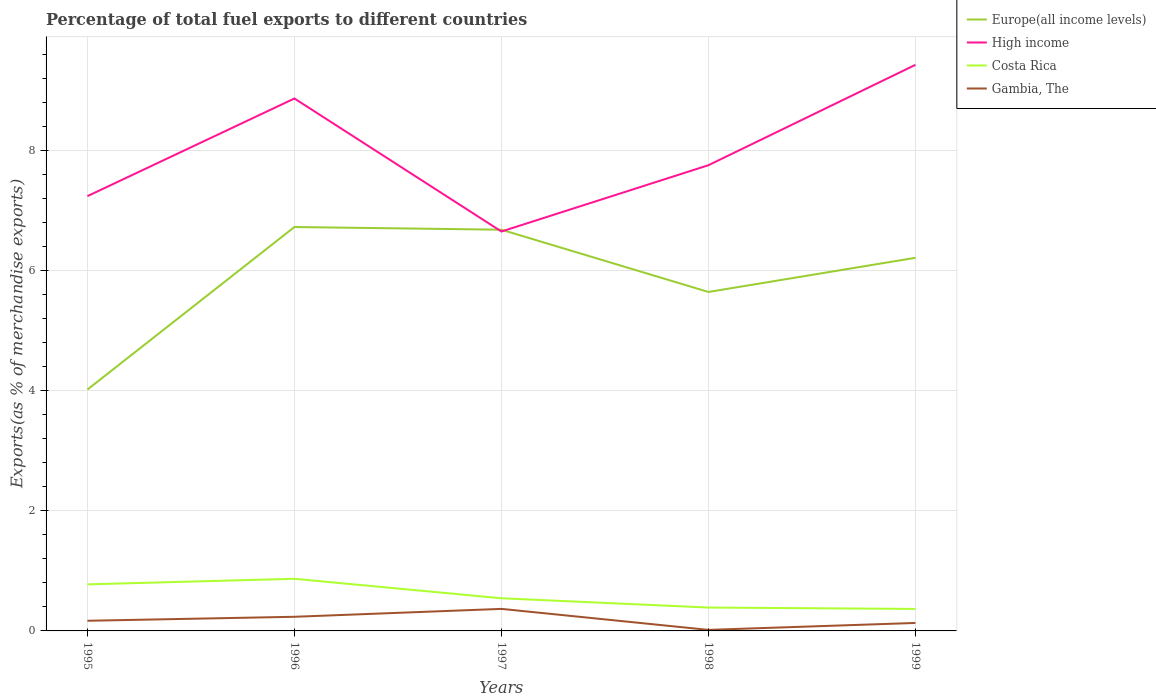How many different coloured lines are there?
Your answer should be very brief. 4. Does the line corresponding to High income intersect with the line corresponding to Europe(all income levels)?
Your answer should be very brief. Yes. Across all years, what is the maximum percentage of exports to different countries in Gambia, The?
Offer a very short reply. 0.02. What is the total percentage of exports to different countries in Costa Rica in the graph?
Ensure brevity in your answer.  0.5. What is the difference between the highest and the second highest percentage of exports to different countries in Costa Rica?
Ensure brevity in your answer.  0.5. What is the difference between the highest and the lowest percentage of exports to different countries in High income?
Your response must be concise. 2. How many years are there in the graph?
Offer a very short reply. 5. What is the difference between two consecutive major ticks on the Y-axis?
Provide a short and direct response. 2. Are the values on the major ticks of Y-axis written in scientific E-notation?
Provide a short and direct response. No. Does the graph contain any zero values?
Provide a succinct answer. No. Does the graph contain grids?
Your answer should be very brief. Yes. How are the legend labels stacked?
Your answer should be compact. Vertical. What is the title of the graph?
Offer a terse response. Percentage of total fuel exports to different countries. Does "Bosnia and Herzegovina" appear as one of the legend labels in the graph?
Provide a short and direct response. No. What is the label or title of the X-axis?
Offer a very short reply. Years. What is the label or title of the Y-axis?
Make the answer very short. Exports(as % of merchandise exports). What is the Exports(as % of merchandise exports) of Europe(all income levels) in 1995?
Keep it short and to the point. 4.02. What is the Exports(as % of merchandise exports) in High income in 1995?
Keep it short and to the point. 7.25. What is the Exports(as % of merchandise exports) in Costa Rica in 1995?
Ensure brevity in your answer.  0.78. What is the Exports(as % of merchandise exports) in Gambia, The in 1995?
Keep it short and to the point. 0.17. What is the Exports(as % of merchandise exports) of Europe(all income levels) in 1996?
Offer a very short reply. 6.73. What is the Exports(as % of merchandise exports) in High income in 1996?
Your response must be concise. 8.87. What is the Exports(as % of merchandise exports) of Costa Rica in 1996?
Give a very brief answer. 0.87. What is the Exports(as % of merchandise exports) of Gambia, The in 1996?
Offer a very short reply. 0.24. What is the Exports(as % of merchandise exports) in Europe(all income levels) in 1997?
Give a very brief answer. 6.69. What is the Exports(as % of merchandise exports) in High income in 1997?
Keep it short and to the point. 6.66. What is the Exports(as % of merchandise exports) of Costa Rica in 1997?
Offer a terse response. 0.54. What is the Exports(as % of merchandise exports) of Gambia, The in 1997?
Provide a short and direct response. 0.37. What is the Exports(as % of merchandise exports) of Europe(all income levels) in 1998?
Offer a terse response. 5.65. What is the Exports(as % of merchandise exports) of High income in 1998?
Provide a short and direct response. 7.76. What is the Exports(as % of merchandise exports) in Costa Rica in 1998?
Ensure brevity in your answer.  0.39. What is the Exports(as % of merchandise exports) of Gambia, The in 1998?
Your answer should be very brief. 0.02. What is the Exports(as % of merchandise exports) in Europe(all income levels) in 1999?
Your answer should be compact. 6.22. What is the Exports(as % of merchandise exports) in High income in 1999?
Your response must be concise. 9.44. What is the Exports(as % of merchandise exports) of Costa Rica in 1999?
Offer a very short reply. 0.37. What is the Exports(as % of merchandise exports) of Gambia, The in 1999?
Ensure brevity in your answer.  0.13. Across all years, what is the maximum Exports(as % of merchandise exports) of Europe(all income levels)?
Your answer should be compact. 6.73. Across all years, what is the maximum Exports(as % of merchandise exports) of High income?
Offer a terse response. 9.44. Across all years, what is the maximum Exports(as % of merchandise exports) in Costa Rica?
Provide a short and direct response. 0.87. Across all years, what is the maximum Exports(as % of merchandise exports) in Gambia, The?
Make the answer very short. 0.37. Across all years, what is the minimum Exports(as % of merchandise exports) of Europe(all income levels)?
Offer a very short reply. 4.02. Across all years, what is the minimum Exports(as % of merchandise exports) in High income?
Your answer should be very brief. 6.66. Across all years, what is the minimum Exports(as % of merchandise exports) in Costa Rica?
Make the answer very short. 0.37. Across all years, what is the minimum Exports(as % of merchandise exports) of Gambia, The?
Offer a terse response. 0.02. What is the total Exports(as % of merchandise exports) of Europe(all income levels) in the graph?
Your answer should be very brief. 29.31. What is the total Exports(as % of merchandise exports) of High income in the graph?
Offer a terse response. 39.98. What is the total Exports(as % of merchandise exports) in Costa Rica in the graph?
Your answer should be very brief. 2.95. What is the total Exports(as % of merchandise exports) of Gambia, The in the graph?
Provide a short and direct response. 0.92. What is the difference between the Exports(as % of merchandise exports) in Europe(all income levels) in 1995 and that in 1996?
Provide a short and direct response. -2.71. What is the difference between the Exports(as % of merchandise exports) of High income in 1995 and that in 1996?
Your answer should be compact. -1.63. What is the difference between the Exports(as % of merchandise exports) of Costa Rica in 1995 and that in 1996?
Your response must be concise. -0.09. What is the difference between the Exports(as % of merchandise exports) in Gambia, The in 1995 and that in 1996?
Give a very brief answer. -0.07. What is the difference between the Exports(as % of merchandise exports) of Europe(all income levels) in 1995 and that in 1997?
Offer a terse response. -2.66. What is the difference between the Exports(as % of merchandise exports) in High income in 1995 and that in 1997?
Provide a succinct answer. 0.59. What is the difference between the Exports(as % of merchandise exports) in Costa Rica in 1995 and that in 1997?
Your answer should be very brief. 0.23. What is the difference between the Exports(as % of merchandise exports) of Gambia, The in 1995 and that in 1997?
Your answer should be very brief. -0.2. What is the difference between the Exports(as % of merchandise exports) of Europe(all income levels) in 1995 and that in 1998?
Your answer should be very brief. -1.63. What is the difference between the Exports(as % of merchandise exports) of High income in 1995 and that in 1998?
Give a very brief answer. -0.52. What is the difference between the Exports(as % of merchandise exports) of Costa Rica in 1995 and that in 1998?
Keep it short and to the point. 0.39. What is the difference between the Exports(as % of merchandise exports) in Gambia, The in 1995 and that in 1998?
Make the answer very short. 0.15. What is the difference between the Exports(as % of merchandise exports) of Europe(all income levels) in 1995 and that in 1999?
Your answer should be very brief. -2.2. What is the difference between the Exports(as % of merchandise exports) of High income in 1995 and that in 1999?
Offer a very short reply. -2.19. What is the difference between the Exports(as % of merchandise exports) in Costa Rica in 1995 and that in 1999?
Your response must be concise. 0.41. What is the difference between the Exports(as % of merchandise exports) of Gambia, The in 1995 and that in 1999?
Keep it short and to the point. 0.04. What is the difference between the Exports(as % of merchandise exports) of Europe(all income levels) in 1996 and that in 1997?
Provide a succinct answer. 0.04. What is the difference between the Exports(as % of merchandise exports) in High income in 1996 and that in 1997?
Offer a very short reply. 2.22. What is the difference between the Exports(as % of merchandise exports) in Costa Rica in 1996 and that in 1997?
Provide a short and direct response. 0.32. What is the difference between the Exports(as % of merchandise exports) in Gambia, The in 1996 and that in 1997?
Provide a succinct answer. -0.13. What is the difference between the Exports(as % of merchandise exports) in Europe(all income levels) in 1996 and that in 1998?
Ensure brevity in your answer.  1.08. What is the difference between the Exports(as % of merchandise exports) of High income in 1996 and that in 1998?
Your answer should be very brief. 1.11. What is the difference between the Exports(as % of merchandise exports) in Costa Rica in 1996 and that in 1998?
Ensure brevity in your answer.  0.48. What is the difference between the Exports(as % of merchandise exports) of Gambia, The in 1996 and that in 1998?
Keep it short and to the point. 0.22. What is the difference between the Exports(as % of merchandise exports) of Europe(all income levels) in 1996 and that in 1999?
Provide a short and direct response. 0.51. What is the difference between the Exports(as % of merchandise exports) in High income in 1996 and that in 1999?
Your answer should be compact. -0.56. What is the difference between the Exports(as % of merchandise exports) of Costa Rica in 1996 and that in 1999?
Your response must be concise. 0.5. What is the difference between the Exports(as % of merchandise exports) in Gambia, The in 1996 and that in 1999?
Provide a short and direct response. 0.1. What is the difference between the Exports(as % of merchandise exports) in Europe(all income levels) in 1997 and that in 1998?
Keep it short and to the point. 1.04. What is the difference between the Exports(as % of merchandise exports) of High income in 1997 and that in 1998?
Offer a very short reply. -1.1. What is the difference between the Exports(as % of merchandise exports) of Costa Rica in 1997 and that in 1998?
Offer a very short reply. 0.15. What is the difference between the Exports(as % of merchandise exports) in Gambia, The in 1997 and that in 1998?
Your response must be concise. 0.35. What is the difference between the Exports(as % of merchandise exports) of Europe(all income levels) in 1997 and that in 1999?
Keep it short and to the point. 0.47. What is the difference between the Exports(as % of merchandise exports) in High income in 1997 and that in 1999?
Your response must be concise. -2.78. What is the difference between the Exports(as % of merchandise exports) of Costa Rica in 1997 and that in 1999?
Your answer should be very brief. 0.18. What is the difference between the Exports(as % of merchandise exports) in Gambia, The in 1997 and that in 1999?
Keep it short and to the point. 0.23. What is the difference between the Exports(as % of merchandise exports) of Europe(all income levels) in 1998 and that in 1999?
Your response must be concise. -0.57. What is the difference between the Exports(as % of merchandise exports) of High income in 1998 and that in 1999?
Provide a succinct answer. -1.67. What is the difference between the Exports(as % of merchandise exports) of Costa Rica in 1998 and that in 1999?
Offer a very short reply. 0.02. What is the difference between the Exports(as % of merchandise exports) of Gambia, The in 1998 and that in 1999?
Offer a very short reply. -0.12. What is the difference between the Exports(as % of merchandise exports) in Europe(all income levels) in 1995 and the Exports(as % of merchandise exports) in High income in 1996?
Provide a short and direct response. -4.85. What is the difference between the Exports(as % of merchandise exports) in Europe(all income levels) in 1995 and the Exports(as % of merchandise exports) in Costa Rica in 1996?
Ensure brevity in your answer.  3.15. What is the difference between the Exports(as % of merchandise exports) in Europe(all income levels) in 1995 and the Exports(as % of merchandise exports) in Gambia, The in 1996?
Give a very brief answer. 3.79. What is the difference between the Exports(as % of merchandise exports) of High income in 1995 and the Exports(as % of merchandise exports) of Costa Rica in 1996?
Keep it short and to the point. 6.38. What is the difference between the Exports(as % of merchandise exports) of High income in 1995 and the Exports(as % of merchandise exports) of Gambia, The in 1996?
Your answer should be very brief. 7.01. What is the difference between the Exports(as % of merchandise exports) of Costa Rica in 1995 and the Exports(as % of merchandise exports) of Gambia, The in 1996?
Provide a short and direct response. 0.54. What is the difference between the Exports(as % of merchandise exports) in Europe(all income levels) in 1995 and the Exports(as % of merchandise exports) in High income in 1997?
Give a very brief answer. -2.63. What is the difference between the Exports(as % of merchandise exports) in Europe(all income levels) in 1995 and the Exports(as % of merchandise exports) in Costa Rica in 1997?
Offer a terse response. 3.48. What is the difference between the Exports(as % of merchandise exports) in Europe(all income levels) in 1995 and the Exports(as % of merchandise exports) in Gambia, The in 1997?
Give a very brief answer. 3.66. What is the difference between the Exports(as % of merchandise exports) of High income in 1995 and the Exports(as % of merchandise exports) of Costa Rica in 1997?
Provide a succinct answer. 6.7. What is the difference between the Exports(as % of merchandise exports) of High income in 1995 and the Exports(as % of merchandise exports) of Gambia, The in 1997?
Provide a succinct answer. 6.88. What is the difference between the Exports(as % of merchandise exports) of Costa Rica in 1995 and the Exports(as % of merchandise exports) of Gambia, The in 1997?
Make the answer very short. 0.41. What is the difference between the Exports(as % of merchandise exports) in Europe(all income levels) in 1995 and the Exports(as % of merchandise exports) in High income in 1998?
Provide a succinct answer. -3.74. What is the difference between the Exports(as % of merchandise exports) of Europe(all income levels) in 1995 and the Exports(as % of merchandise exports) of Costa Rica in 1998?
Keep it short and to the point. 3.63. What is the difference between the Exports(as % of merchandise exports) in Europe(all income levels) in 1995 and the Exports(as % of merchandise exports) in Gambia, The in 1998?
Your response must be concise. 4.01. What is the difference between the Exports(as % of merchandise exports) of High income in 1995 and the Exports(as % of merchandise exports) of Costa Rica in 1998?
Provide a succinct answer. 6.86. What is the difference between the Exports(as % of merchandise exports) in High income in 1995 and the Exports(as % of merchandise exports) in Gambia, The in 1998?
Your answer should be compact. 7.23. What is the difference between the Exports(as % of merchandise exports) of Costa Rica in 1995 and the Exports(as % of merchandise exports) of Gambia, The in 1998?
Give a very brief answer. 0.76. What is the difference between the Exports(as % of merchandise exports) in Europe(all income levels) in 1995 and the Exports(as % of merchandise exports) in High income in 1999?
Provide a short and direct response. -5.41. What is the difference between the Exports(as % of merchandise exports) of Europe(all income levels) in 1995 and the Exports(as % of merchandise exports) of Costa Rica in 1999?
Offer a very short reply. 3.66. What is the difference between the Exports(as % of merchandise exports) in Europe(all income levels) in 1995 and the Exports(as % of merchandise exports) in Gambia, The in 1999?
Your answer should be very brief. 3.89. What is the difference between the Exports(as % of merchandise exports) in High income in 1995 and the Exports(as % of merchandise exports) in Costa Rica in 1999?
Offer a very short reply. 6.88. What is the difference between the Exports(as % of merchandise exports) of High income in 1995 and the Exports(as % of merchandise exports) of Gambia, The in 1999?
Your answer should be very brief. 7.11. What is the difference between the Exports(as % of merchandise exports) of Costa Rica in 1995 and the Exports(as % of merchandise exports) of Gambia, The in 1999?
Provide a succinct answer. 0.64. What is the difference between the Exports(as % of merchandise exports) of Europe(all income levels) in 1996 and the Exports(as % of merchandise exports) of High income in 1997?
Ensure brevity in your answer.  0.07. What is the difference between the Exports(as % of merchandise exports) of Europe(all income levels) in 1996 and the Exports(as % of merchandise exports) of Costa Rica in 1997?
Your response must be concise. 6.19. What is the difference between the Exports(as % of merchandise exports) in Europe(all income levels) in 1996 and the Exports(as % of merchandise exports) in Gambia, The in 1997?
Provide a short and direct response. 6.36. What is the difference between the Exports(as % of merchandise exports) in High income in 1996 and the Exports(as % of merchandise exports) in Costa Rica in 1997?
Your response must be concise. 8.33. What is the difference between the Exports(as % of merchandise exports) in High income in 1996 and the Exports(as % of merchandise exports) in Gambia, The in 1997?
Offer a very short reply. 8.51. What is the difference between the Exports(as % of merchandise exports) of Costa Rica in 1996 and the Exports(as % of merchandise exports) of Gambia, The in 1997?
Offer a terse response. 0.5. What is the difference between the Exports(as % of merchandise exports) of Europe(all income levels) in 1996 and the Exports(as % of merchandise exports) of High income in 1998?
Your answer should be very brief. -1.03. What is the difference between the Exports(as % of merchandise exports) of Europe(all income levels) in 1996 and the Exports(as % of merchandise exports) of Costa Rica in 1998?
Provide a succinct answer. 6.34. What is the difference between the Exports(as % of merchandise exports) of Europe(all income levels) in 1996 and the Exports(as % of merchandise exports) of Gambia, The in 1998?
Offer a terse response. 6.71. What is the difference between the Exports(as % of merchandise exports) of High income in 1996 and the Exports(as % of merchandise exports) of Costa Rica in 1998?
Make the answer very short. 8.48. What is the difference between the Exports(as % of merchandise exports) of High income in 1996 and the Exports(as % of merchandise exports) of Gambia, The in 1998?
Give a very brief answer. 8.86. What is the difference between the Exports(as % of merchandise exports) in Costa Rica in 1996 and the Exports(as % of merchandise exports) in Gambia, The in 1998?
Provide a short and direct response. 0.85. What is the difference between the Exports(as % of merchandise exports) in Europe(all income levels) in 1996 and the Exports(as % of merchandise exports) in High income in 1999?
Provide a short and direct response. -2.7. What is the difference between the Exports(as % of merchandise exports) of Europe(all income levels) in 1996 and the Exports(as % of merchandise exports) of Costa Rica in 1999?
Ensure brevity in your answer.  6.37. What is the difference between the Exports(as % of merchandise exports) in Europe(all income levels) in 1996 and the Exports(as % of merchandise exports) in Gambia, The in 1999?
Your answer should be compact. 6.6. What is the difference between the Exports(as % of merchandise exports) of High income in 1996 and the Exports(as % of merchandise exports) of Costa Rica in 1999?
Ensure brevity in your answer.  8.51. What is the difference between the Exports(as % of merchandise exports) of High income in 1996 and the Exports(as % of merchandise exports) of Gambia, The in 1999?
Make the answer very short. 8.74. What is the difference between the Exports(as % of merchandise exports) in Costa Rica in 1996 and the Exports(as % of merchandise exports) in Gambia, The in 1999?
Your answer should be compact. 0.74. What is the difference between the Exports(as % of merchandise exports) of Europe(all income levels) in 1997 and the Exports(as % of merchandise exports) of High income in 1998?
Provide a short and direct response. -1.07. What is the difference between the Exports(as % of merchandise exports) of Europe(all income levels) in 1997 and the Exports(as % of merchandise exports) of Costa Rica in 1998?
Offer a very short reply. 6.3. What is the difference between the Exports(as % of merchandise exports) of Europe(all income levels) in 1997 and the Exports(as % of merchandise exports) of Gambia, The in 1998?
Your response must be concise. 6.67. What is the difference between the Exports(as % of merchandise exports) of High income in 1997 and the Exports(as % of merchandise exports) of Costa Rica in 1998?
Ensure brevity in your answer.  6.27. What is the difference between the Exports(as % of merchandise exports) in High income in 1997 and the Exports(as % of merchandise exports) in Gambia, The in 1998?
Make the answer very short. 6.64. What is the difference between the Exports(as % of merchandise exports) of Costa Rica in 1997 and the Exports(as % of merchandise exports) of Gambia, The in 1998?
Make the answer very short. 0.53. What is the difference between the Exports(as % of merchandise exports) of Europe(all income levels) in 1997 and the Exports(as % of merchandise exports) of High income in 1999?
Ensure brevity in your answer.  -2.75. What is the difference between the Exports(as % of merchandise exports) in Europe(all income levels) in 1997 and the Exports(as % of merchandise exports) in Costa Rica in 1999?
Ensure brevity in your answer.  6.32. What is the difference between the Exports(as % of merchandise exports) in Europe(all income levels) in 1997 and the Exports(as % of merchandise exports) in Gambia, The in 1999?
Offer a very short reply. 6.55. What is the difference between the Exports(as % of merchandise exports) in High income in 1997 and the Exports(as % of merchandise exports) in Costa Rica in 1999?
Make the answer very short. 6.29. What is the difference between the Exports(as % of merchandise exports) in High income in 1997 and the Exports(as % of merchandise exports) in Gambia, The in 1999?
Provide a succinct answer. 6.52. What is the difference between the Exports(as % of merchandise exports) in Costa Rica in 1997 and the Exports(as % of merchandise exports) in Gambia, The in 1999?
Provide a succinct answer. 0.41. What is the difference between the Exports(as % of merchandise exports) of Europe(all income levels) in 1998 and the Exports(as % of merchandise exports) of High income in 1999?
Ensure brevity in your answer.  -3.79. What is the difference between the Exports(as % of merchandise exports) in Europe(all income levels) in 1998 and the Exports(as % of merchandise exports) in Costa Rica in 1999?
Provide a short and direct response. 5.28. What is the difference between the Exports(as % of merchandise exports) in Europe(all income levels) in 1998 and the Exports(as % of merchandise exports) in Gambia, The in 1999?
Provide a short and direct response. 5.52. What is the difference between the Exports(as % of merchandise exports) of High income in 1998 and the Exports(as % of merchandise exports) of Costa Rica in 1999?
Provide a succinct answer. 7.4. What is the difference between the Exports(as % of merchandise exports) of High income in 1998 and the Exports(as % of merchandise exports) of Gambia, The in 1999?
Your answer should be very brief. 7.63. What is the difference between the Exports(as % of merchandise exports) of Costa Rica in 1998 and the Exports(as % of merchandise exports) of Gambia, The in 1999?
Your response must be concise. 0.26. What is the average Exports(as % of merchandise exports) of Europe(all income levels) per year?
Give a very brief answer. 5.86. What is the average Exports(as % of merchandise exports) of High income per year?
Give a very brief answer. 8. What is the average Exports(as % of merchandise exports) of Costa Rica per year?
Offer a very short reply. 0.59. What is the average Exports(as % of merchandise exports) of Gambia, The per year?
Give a very brief answer. 0.18. In the year 1995, what is the difference between the Exports(as % of merchandise exports) of Europe(all income levels) and Exports(as % of merchandise exports) of High income?
Offer a terse response. -3.22. In the year 1995, what is the difference between the Exports(as % of merchandise exports) in Europe(all income levels) and Exports(as % of merchandise exports) in Costa Rica?
Ensure brevity in your answer.  3.25. In the year 1995, what is the difference between the Exports(as % of merchandise exports) in Europe(all income levels) and Exports(as % of merchandise exports) in Gambia, The?
Offer a very short reply. 3.85. In the year 1995, what is the difference between the Exports(as % of merchandise exports) of High income and Exports(as % of merchandise exports) of Costa Rica?
Your answer should be very brief. 6.47. In the year 1995, what is the difference between the Exports(as % of merchandise exports) in High income and Exports(as % of merchandise exports) in Gambia, The?
Your response must be concise. 7.08. In the year 1995, what is the difference between the Exports(as % of merchandise exports) in Costa Rica and Exports(as % of merchandise exports) in Gambia, The?
Provide a succinct answer. 0.61. In the year 1996, what is the difference between the Exports(as % of merchandise exports) of Europe(all income levels) and Exports(as % of merchandise exports) of High income?
Keep it short and to the point. -2.14. In the year 1996, what is the difference between the Exports(as % of merchandise exports) of Europe(all income levels) and Exports(as % of merchandise exports) of Costa Rica?
Your answer should be compact. 5.86. In the year 1996, what is the difference between the Exports(as % of merchandise exports) of Europe(all income levels) and Exports(as % of merchandise exports) of Gambia, The?
Provide a succinct answer. 6.5. In the year 1996, what is the difference between the Exports(as % of merchandise exports) in High income and Exports(as % of merchandise exports) in Costa Rica?
Give a very brief answer. 8.01. In the year 1996, what is the difference between the Exports(as % of merchandise exports) in High income and Exports(as % of merchandise exports) in Gambia, The?
Keep it short and to the point. 8.64. In the year 1996, what is the difference between the Exports(as % of merchandise exports) of Costa Rica and Exports(as % of merchandise exports) of Gambia, The?
Give a very brief answer. 0.63. In the year 1997, what is the difference between the Exports(as % of merchandise exports) in Europe(all income levels) and Exports(as % of merchandise exports) in Costa Rica?
Ensure brevity in your answer.  6.14. In the year 1997, what is the difference between the Exports(as % of merchandise exports) of Europe(all income levels) and Exports(as % of merchandise exports) of Gambia, The?
Offer a very short reply. 6.32. In the year 1997, what is the difference between the Exports(as % of merchandise exports) of High income and Exports(as % of merchandise exports) of Costa Rica?
Provide a short and direct response. 6.11. In the year 1997, what is the difference between the Exports(as % of merchandise exports) in High income and Exports(as % of merchandise exports) in Gambia, The?
Provide a short and direct response. 6.29. In the year 1997, what is the difference between the Exports(as % of merchandise exports) in Costa Rica and Exports(as % of merchandise exports) in Gambia, The?
Your response must be concise. 0.18. In the year 1998, what is the difference between the Exports(as % of merchandise exports) in Europe(all income levels) and Exports(as % of merchandise exports) in High income?
Offer a terse response. -2.11. In the year 1998, what is the difference between the Exports(as % of merchandise exports) in Europe(all income levels) and Exports(as % of merchandise exports) in Costa Rica?
Give a very brief answer. 5.26. In the year 1998, what is the difference between the Exports(as % of merchandise exports) of Europe(all income levels) and Exports(as % of merchandise exports) of Gambia, The?
Your answer should be very brief. 5.63. In the year 1998, what is the difference between the Exports(as % of merchandise exports) of High income and Exports(as % of merchandise exports) of Costa Rica?
Offer a terse response. 7.37. In the year 1998, what is the difference between the Exports(as % of merchandise exports) of High income and Exports(as % of merchandise exports) of Gambia, The?
Give a very brief answer. 7.74. In the year 1998, what is the difference between the Exports(as % of merchandise exports) in Costa Rica and Exports(as % of merchandise exports) in Gambia, The?
Your answer should be compact. 0.37. In the year 1999, what is the difference between the Exports(as % of merchandise exports) in Europe(all income levels) and Exports(as % of merchandise exports) in High income?
Give a very brief answer. -3.22. In the year 1999, what is the difference between the Exports(as % of merchandise exports) in Europe(all income levels) and Exports(as % of merchandise exports) in Costa Rica?
Provide a short and direct response. 5.85. In the year 1999, what is the difference between the Exports(as % of merchandise exports) of Europe(all income levels) and Exports(as % of merchandise exports) of Gambia, The?
Provide a succinct answer. 6.09. In the year 1999, what is the difference between the Exports(as % of merchandise exports) of High income and Exports(as % of merchandise exports) of Costa Rica?
Provide a short and direct response. 9.07. In the year 1999, what is the difference between the Exports(as % of merchandise exports) in High income and Exports(as % of merchandise exports) in Gambia, The?
Ensure brevity in your answer.  9.3. In the year 1999, what is the difference between the Exports(as % of merchandise exports) in Costa Rica and Exports(as % of merchandise exports) in Gambia, The?
Offer a terse response. 0.23. What is the ratio of the Exports(as % of merchandise exports) in Europe(all income levels) in 1995 to that in 1996?
Provide a short and direct response. 0.6. What is the ratio of the Exports(as % of merchandise exports) of High income in 1995 to that in 1996?
Provide a succinct answer. 0.82. What is the ratio of the Exports(as % of merchandise exports) of Costa Rica in 1995 to that in 1996?
Offer a terse response. 0.89. What is the ratio of the Exports(as % of merchandise exports) in Gambia, The in 1995 to that in 1996?
Make the answer very short. 0.72. What is the ratio of the Exports(as % of merchandise exports) in Europe(all income levels) in 1995 to that in 1997?
Provide a succinct answer. 0.6. What is the ratio of the Exports(as % of merchandise exports) of High income in 1995 to that in 1997?
Keep it short and to the point. 1.09. What is the ratio of the Exports(as % of merchandise exports) in Costa Rica in 1995 to that in 1997?
Offer a very short reply. 1.43. What is the ratio of the Exports(as % of merchandise exports) of Gambia, The in 1995 to that in 1997?
Ensure brevity in your answer.  0.46. What is the ratio of the Exports(as % of merchandise exports) in Europe(all income levels) in 1995 to that in 1998?
Offer a terse response. 0.71. What is the ratio of the Exports(as % of merchandise exports) of High income in 1995 to that in 1998?
Offer a terse response. 0.93. What is the ratio of the Exports(as % of merchandise exports) in Costa Rica in 1995 to that in 1998?
Offer a very short reply. 1.99. What is the ratio of the Exports(as % of merchandise exports) of Gambia, The in 1995 to that in 1998?
Your answer should be very brief. 9.74. What is the ratio of the Exports(as % of merchandise exports) of Europe(all income levels) in 1995 to that in 1999?
Offer a terse response. 0.65. What is the ratio of the Exports(as % of merchandise exports) of High income in 1995 to that in 1999?
Offer a very short reply. 0.77. What is the ratio of the Exports(as % of merchandise exports) of Costa Rica in 1995 to that in 1999?
Provide a short and direct response. 2.12. What is the ratio of the Exports(as % of merchandise exports) of Gambia, The in 1995 to that in 1999?
Your answer should be very brief. 1.28. What is the ratio of the Exports(as % of merchandise exports) of Europe(all income levels) in 1996 to that in 1997?
Keep it short and to the point. 1.01. What is the ratio of the Exports(as % of merchandise exports) of High income in 1996 to that in 1997?
Offer a terse response. 1.33. What is the ratio of the Exports(as % of merchandise exports) in Costa Rica in 1996 to that in 1997?
Your answer should be very brief. 1.6. What is the ratio of the Exports(as % of merchandise exports) of Gambia, The in 1996 to that in 1997?
Your answer should be very brief. 0.64. What is the ratio of the Exports(as % of merchandise exports) of Europe(all income levels) in 1996 to that in 1998?
Your answer should be very brief. 1.19. What is the ratio of the Exports(as % of merchandise exports) of High income in 1996 to that in 1998?
Your response must be concise. 1.14. What is the ratio of the Exports(as % of merchandise exports) of Costa Rica in 1996 to that in 1998?
Offer a very short reply. 2.23. What is the ratio of the Exports(as % of merchandise exports) of Gambia, The in 1996 to that in 1998?
Your response must be concise. 13.55. What is the ratio of the Exports(as % of merchandise exports) in Europe(all income levels) in 1996 to that in 1999?
Your answer should be compact. 1.08. What is the ratio of the Exports(as % of merchandise exports) in High income in 1996 to that in 1999?
Your answer should be very brief. 0.94. What is the ratio of the Exports(as % of merchandise exports) in Costa Rica in 1996 to that in 1999?
Your response must be concise. 2.37. What is the ratio of the Exports(as % of merchandise exports) in Gambia, The in 1996 to that in 1999?
Make the answer very short. 1.78. What is the ratio of the Exports(as % of merchandise exports) in Europe(all income levels) in 1997 to that in 1998?
Ensure brevity in your answer.  1.18. What is the ratio of the Exports(as % of merchandise exports) in High income in 1997 to that in 1998?
Your answer should be very brief. 0.86. What is the ratio of the Exports(as % of merchandise exports) in Costa Rica in 1997 to that in 1998?
Give a very brief answer. 1.4. What is the ratio of the Exports(as % of merchandise exports) in Gambia, The in 1997 to that in 1998?
Offer a terse response. 21.12. What is the ratio of the Exports(as % of merchandise exports) in Europe(all income levels) in 1997 to that in 1999?
Your answer should be very brief. 1.08. What is the ratio of the Exports(as % of merchandise exports) of High income in 1997 to that in 1999?
Offer a very short reply. 0.71. What is the ratio of the Exports(as % of merchandise exports) of Costa Rica in 1997 to that in 1999?
Your answer should be very brief. 1.48. What is the ratio of the Exports(as % of merchandise exports) in Gambia, The in 1997 to that in 1999?
Offer a terse response. 2.77. What is the ratio of the Exports(as % of merchandise exports) of Europe(all income levels) in 1998 to that in 1999?
Provide a short and direct response. 0.91. What is the ratio of the Exports(as % of merchandise exports) in High income in 1998 to that in 1999?
Offer a very short reply. 0.82. What is the ratio of the Exports(as % of merchandise exports) of Costa Rica in 1998 to that in 1999?
Offer a very short reply. 1.06. What is the ratio of the Exports(as % of merchandise exports) of Gambia, The in 1998 to that in 1999?
Provide a short and direct response. 0.13. What is the difference between the highest and the second highest Exports(as % of merchandise exports) in Europe(all income levels)?
Offer a terse response. 0.04. What is the difference between the highest and the second highest Exports(as % of merchandise exports) of High income?
Keep it short and to the point. 0.56. What is the difference between the highest and the second highest Exports(as % of merchandise exports) in Costa Rica?
Offer a terse response. 0.09. What is the difference between the highest and the second highest Exports(as % of merchandise exports) in Gambia, The?
Keep it short and to the point. 0.13. What is the difference between the highest and the lowest Exports(as % of merchandise exports) of Europe(all income levels)?
Your answer should be compact. 2.71. What is the difference between the highest and the lowest Exports(as % of merchandise exports) of High income?
Provide a succinct answer. 2.78. What is the difference between the highest and the lowest Exports(as % of merchandise exports) of Costa Rica?
Keep it short and to the point. 0.5. What is the difference between the highest and the lowest Exports(as % of merchandise exports) in Gambia, The?
Your answer should be very brief. 0.35. 